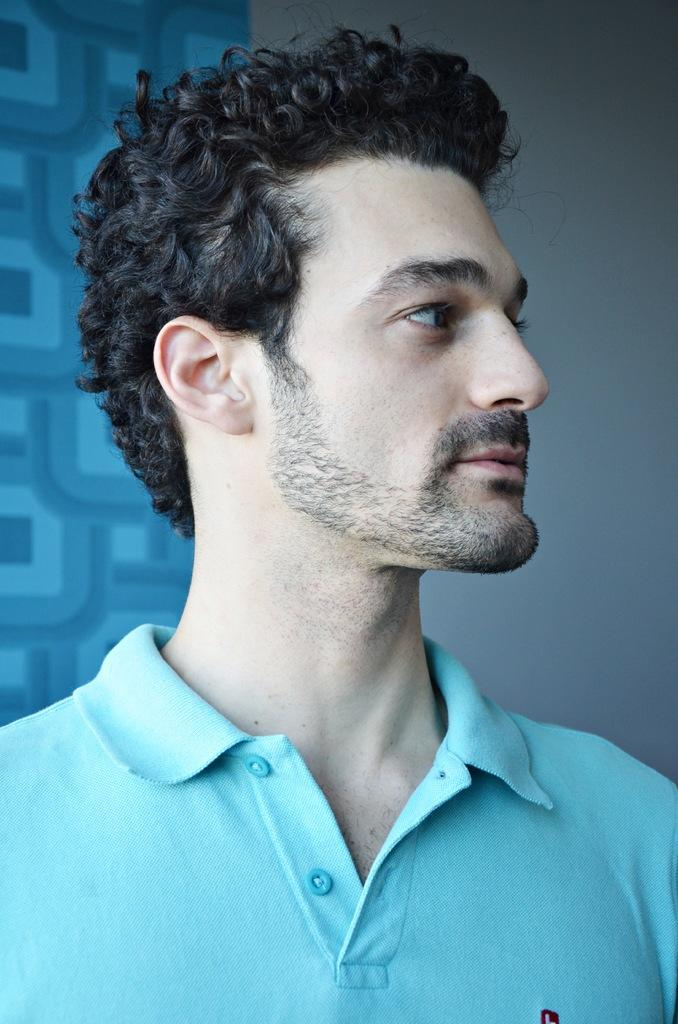Who is present in the image? There is a man in the image. What is the man doing in the image? The man is looking to the right side. What is the man wearing in the image? The man is wearing a blue t-shirt. What can be seen in the background of the image? There is a wall in the background of the image. What type of gun is the man holding in the image? There is no gun present in the image; the man is not holding any object. 